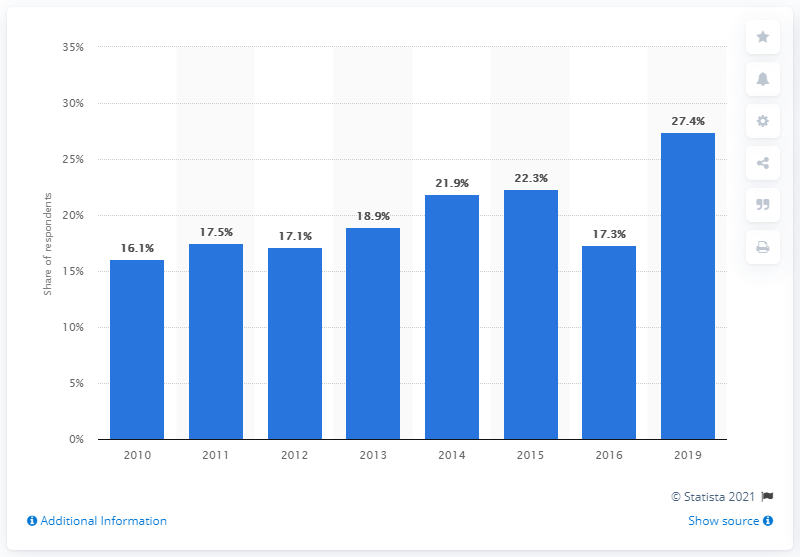Outline some significant characteristics in this image. In 2019, it was reported that 27.4% of school children read blogs. 